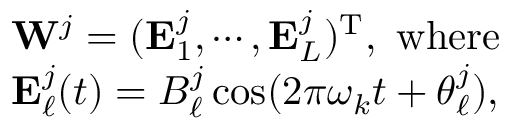Convert formula to latex. <formula><loc_0><loc_0><loc_500><loc_500>\begin{array} { r l } & { W ^ { j } = ( E _ { 1 } ^ { j } , \cdots , E _ { L } ^ { j } ) ^ { T } , w h e r e } \\ & { E _ { \ell } ^ { j } ( t ) = B _ { \ell } ^ { j } \cos ( 2 \pi \omega _ { k } t + \theta _ { \ell } ^ { j } ) , } \end{array}</formula> 